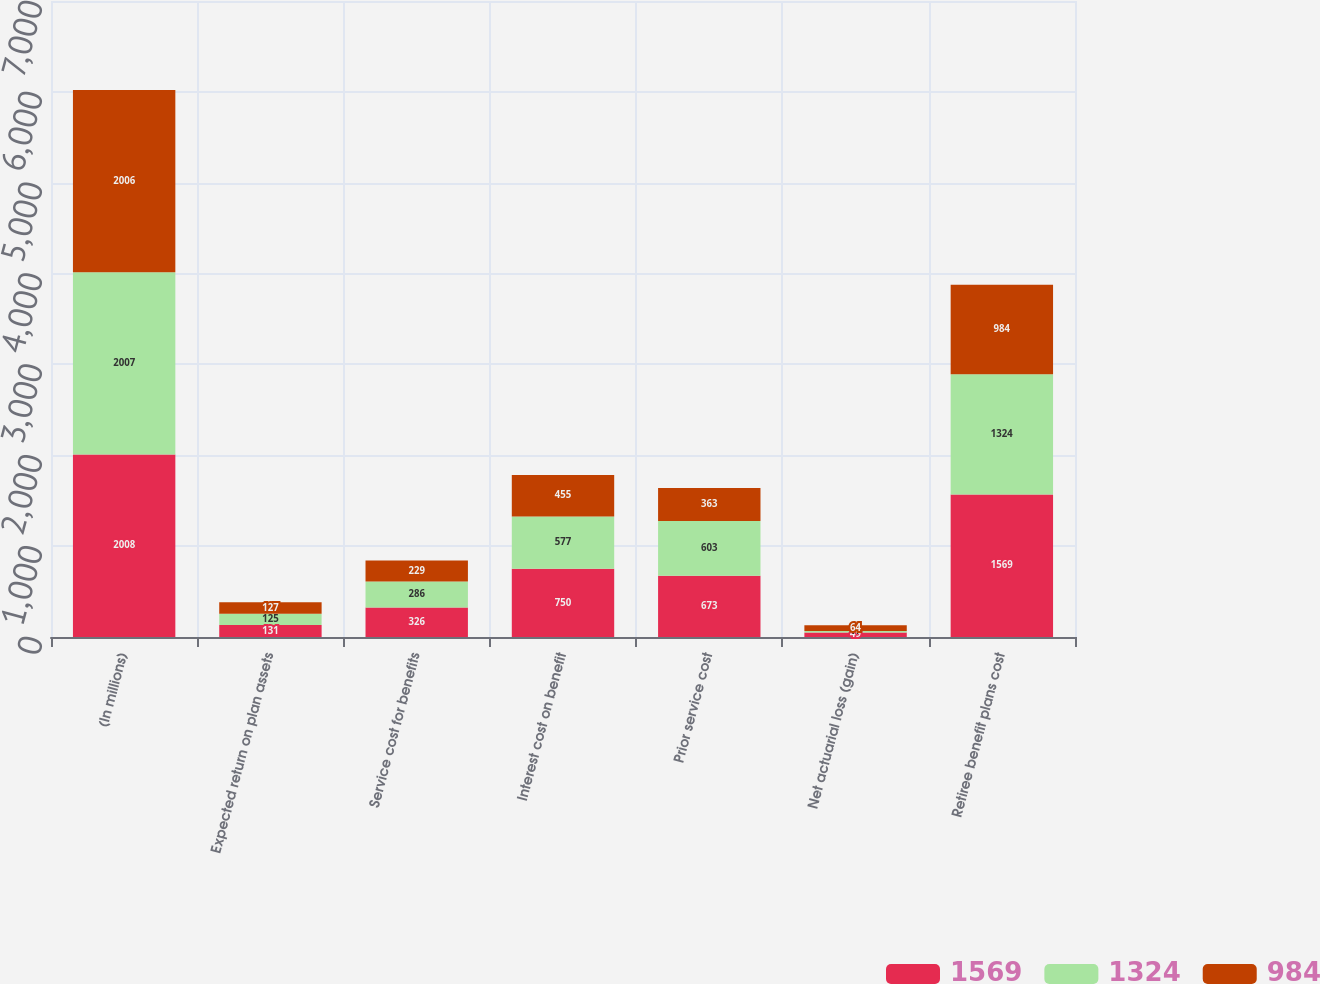Convert chart. <chart><loc_0><loc_0><loc_500><loc_500><stacked_bar_chart><ecel><fcel>(In millions)<fcel>Expected return on plan assets<fcel>Service cost for benefits<fcel>Interest cost on benefit<fcel>Prior service cost<fcel>Net actuarial loss (gain)<fcel>Retiree benefit plans cost<nl><fcel>1569<fcel>2008<fcel>131<fcel>326<fcel>750<fcel>673<fcel>49<fcel>1569<nl><fcel>1324<fcel>2007<fcel>125<fcel>286<fcel>577<fcel>603<fcel>17<fcel>1324<nl><fcel>984<fcel>2006<fcel>127<fcel>229<fcel>455<fcel>363<fcel>64<fcel>984<nl></chart> 